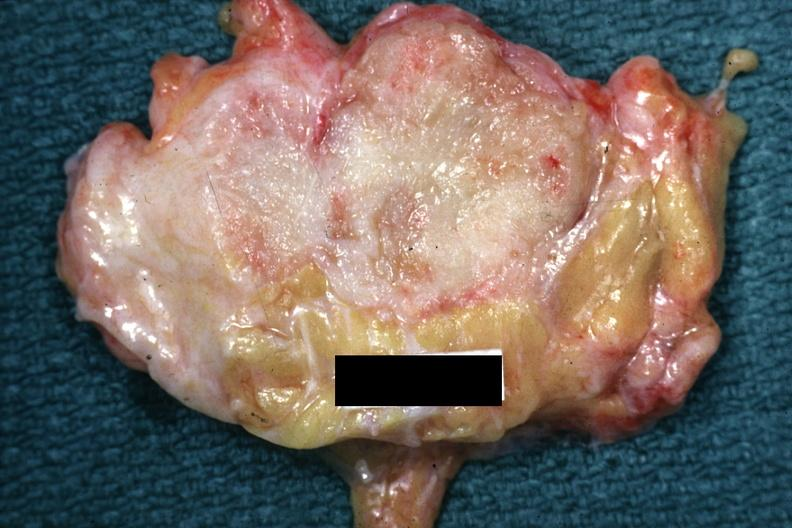where is this area in the body?
Answer the question using a single word or phrase. Breast 